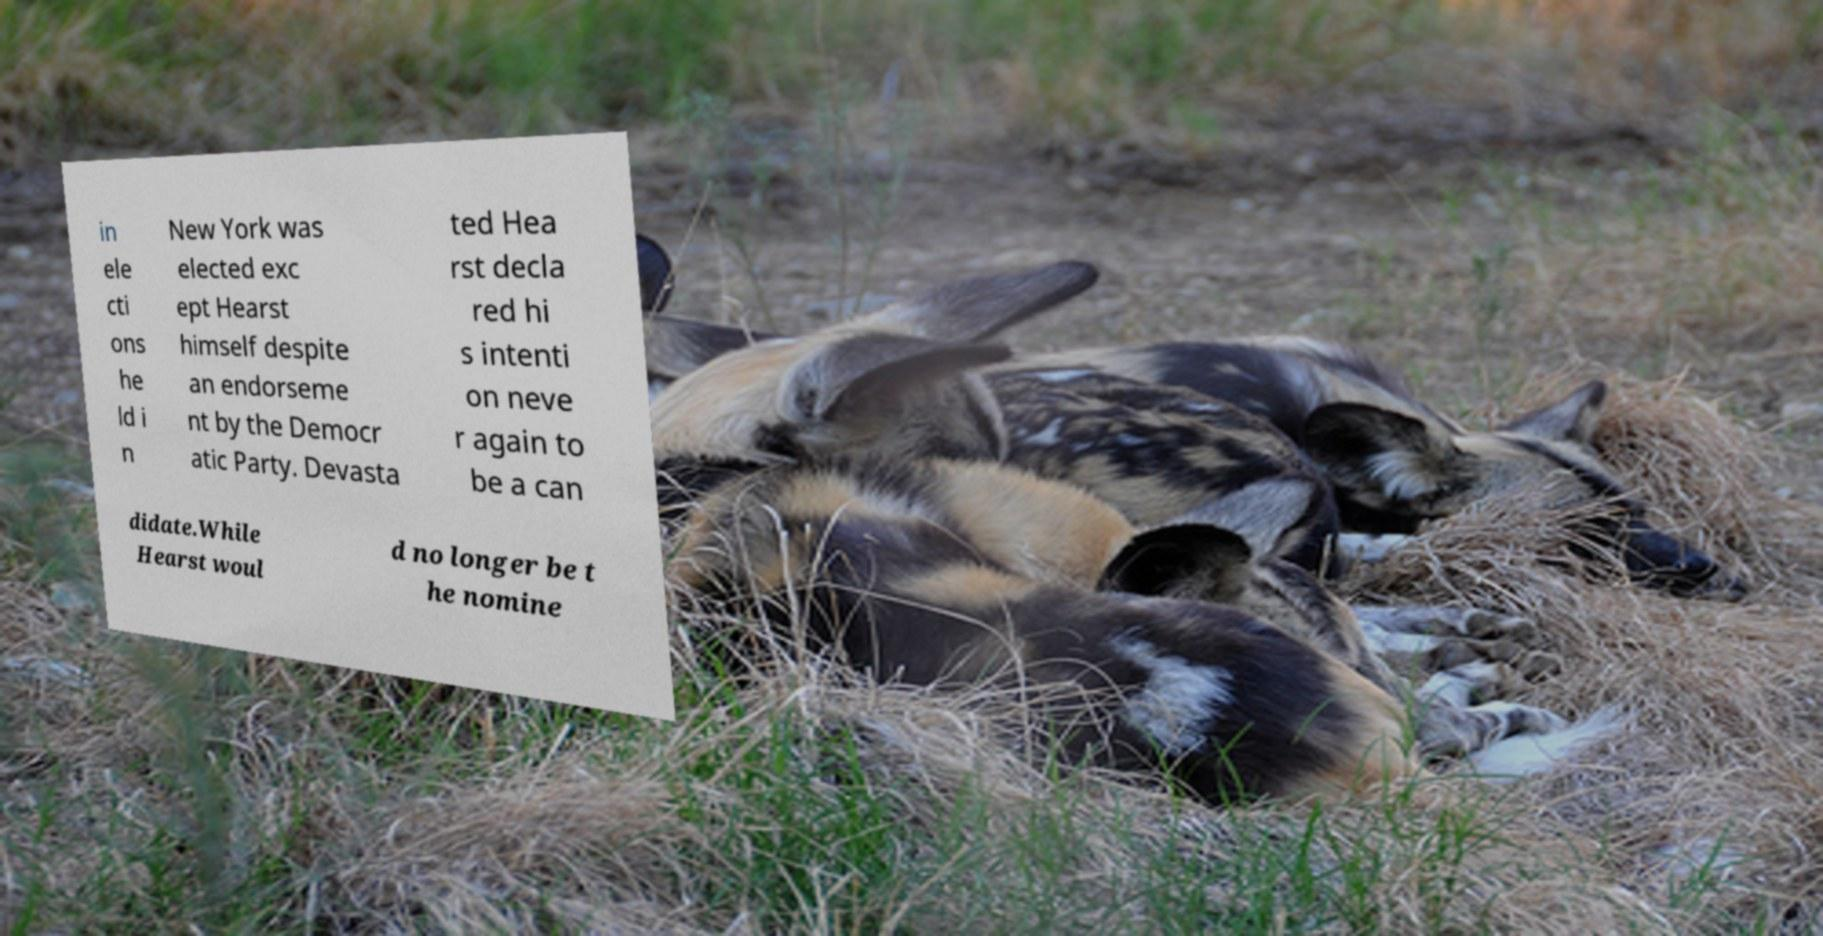Can you read and provide the text displayed in the image?This photo seems to have some interesting text. Can you extract and type it out for me? in ele cti ons he ld i n New York was elected exc ept Hearst himself despite an endorseme nt by the Democr atic Party. Devasta ted Hea rst decla red hi s intenti on neve r again to be a can didate.While Hearst woul d no longer be t he nomine 